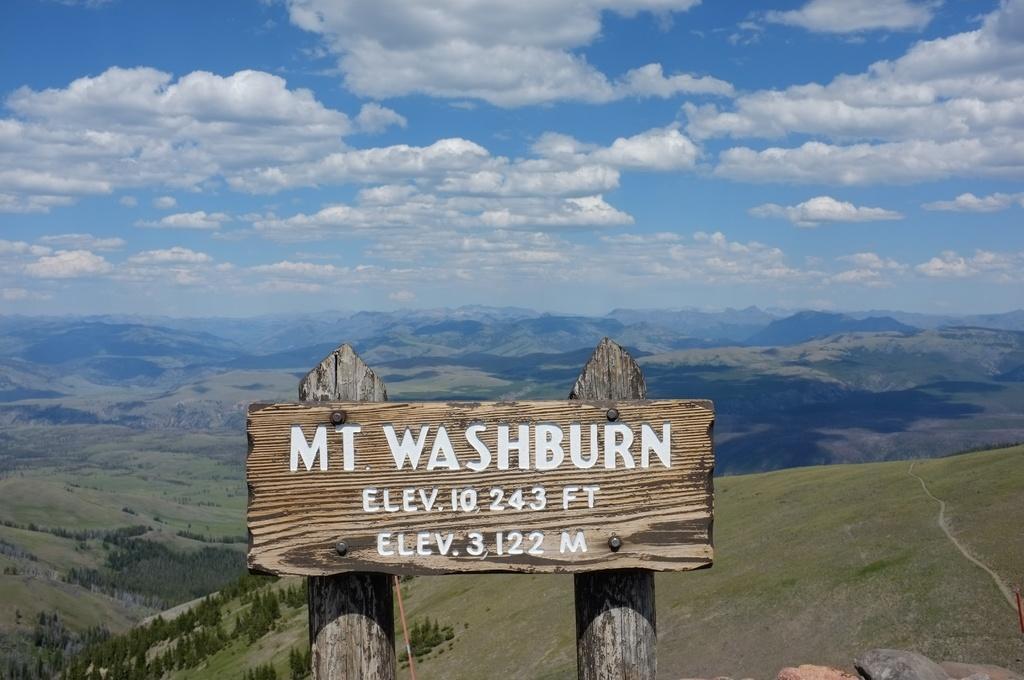Describe this image in one or two sentences. In the front of the image we can see an information board on the wooden stands. Something is written on the information board. In the background of the image there are trees, hills, grass and the cloudy sky.   